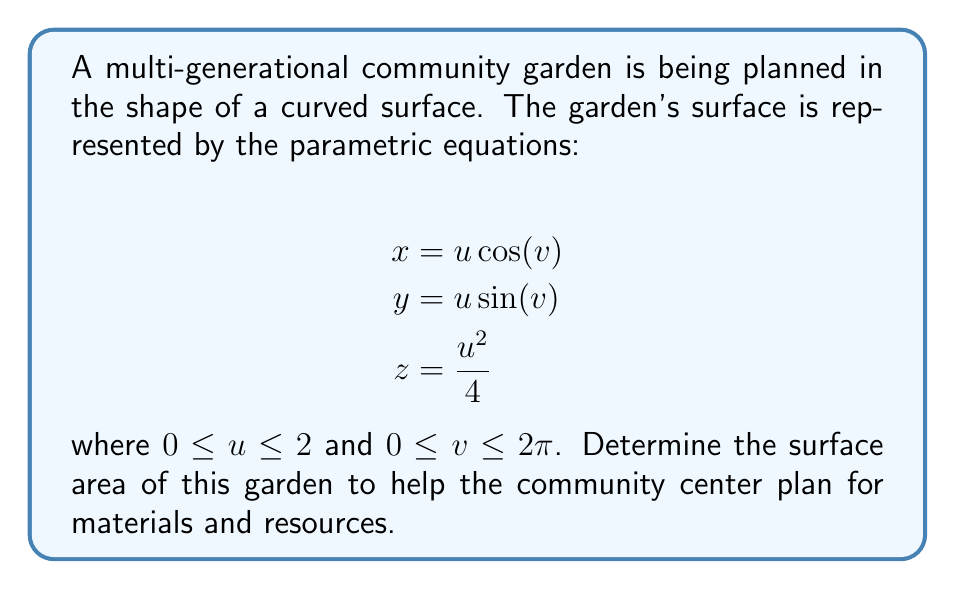Provide a solution to this math problem. To find the surface area, we need to use the surface integral formula:

$$A = \int\int_S \sqrt{EG - F^2} \, du \, dv$$

where $E$, $F$, and $G$ are the coefficients of the first fundamental form.

Step 1: Calculate partial derivatives
$$\frac{\partial x}{\partial u} = \cos(v), \quad \frac{\partial x}{\partial v} = -u \sin(v)$$
$$\frac{\partial y}{\partial u} = \sin(v), \quad \frac{\partial y}{\partial v} = u \cos(v)$$
$$\frac{\partial z}{\partial u} = \frac{u}{2}, \quad \frac{\partial z}{\partial v} = 0$$

Step 2: Calculate $E$, $F$, and $G$
$$E = (\frac{\partial x}{\partial u})^2 + (\frac{\partial y}{\partial u})^2 + (\frac{\partial z}{\partial u})^2 = \cos^2(v) + \sin^2(v) + \frac{u^2}{4} = 1 + \frac{u^2}{4}$$

$$F = \frac{\partial x}{\partial u}\frac{\partial x}{\partial v} + \frac{\partial y}{\partial u}\frac{\partial y}{\partial v} + \frac{\partial z}{\partial u}\frac{\partial z}{\partial v} = -u\sin(v)\cos(v) + u\sin(v)\cos(v) + 0 = 0$$

$$G = (\frac{\partial x}{\partial v})^2 + (\frac{\partial y}{\partial v})^2 + (\frac{\partial z}{\partial v})^2 = u^2\sin^2(v) + u^2\cos^2(v) + 0 = u^2$$

Step 3: Calculate $EG - F^2$
$$EG - F^2 = (1 + \frac{u^2}{4})u^2 - 0^2 = u^2 + \frac{u^4}{4}$$

Step 4: Set up the surface integral
$$A = \int_0^{2\pi} \int_0^2 \sqrt{u^2 + \frac{u^4}{4}} \, du \, dv$$

Step 5: Simplify the integrand
$$A = \int_0^{2\pi} \int_0^2 u\sqrt{1 + \frac{u^2}{4}} \, du \, dv$$

Step 6: Solve the inner integral
Let $t = 1 + \frac{u^2}{4}$, then $du = \frac{2dt}{u}$
$$\int_0^2 u\sqrt{1 + \frac{u^2}{4}} \, du = 2\int_1^2 t \, dt = 2[t^2/2]_1^2 = 2(2 - \frac{1}{2}) = 3$$

Step 7: Solve the outer integral
$$A = \int_0^{2\pi} 3 \, dv = 3 \cdot 2\pi = 6\pi$$

Therefore, the surface area of the community garden is $6\pi$ square units.
Answer: $6\pi$ square units 